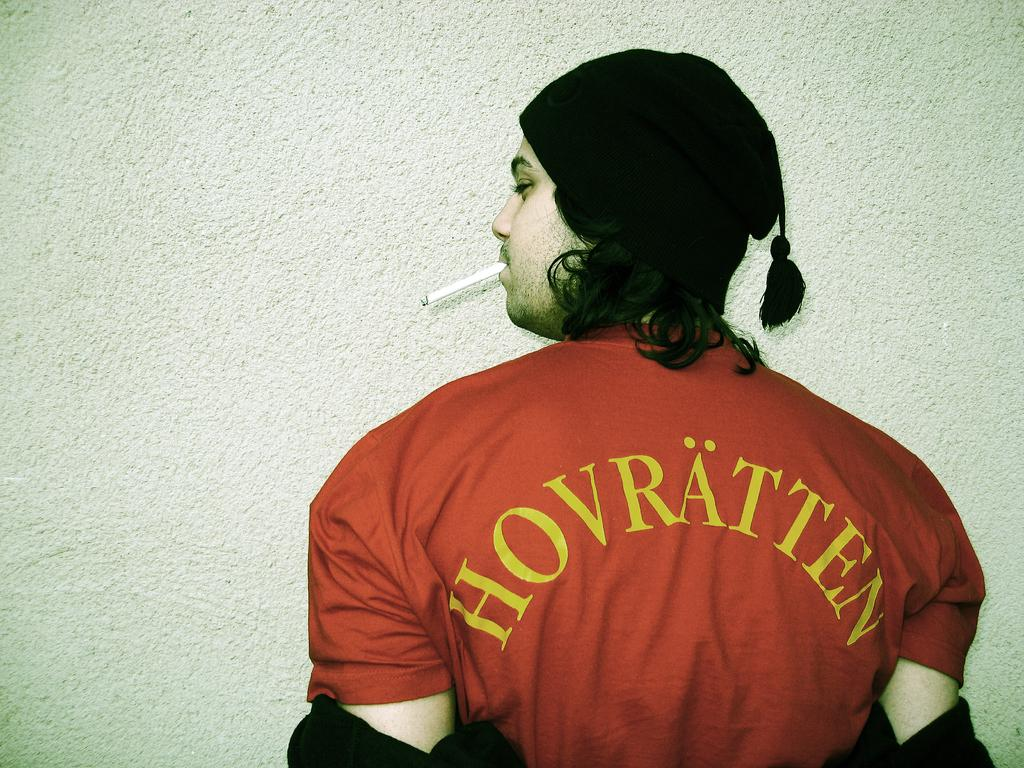<image>
Share a concise interpretation of the image provided. An unshaven guy wearing a HOVRATTEN shirt smokes a cigarette. 